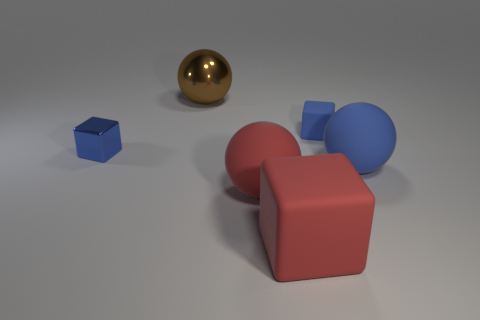Add 3 small cyan cylinders. How many objects exist? 9 Add 4 small blue things. How many small blue things are left? 6 Add 4 small cubes. How many small cubes exist? 6 Subtract 1 brown spheres. How many objects are left? 5 Subtract all blue shiny objects. Subtract all red matte cubes. How many objects are left? 4 